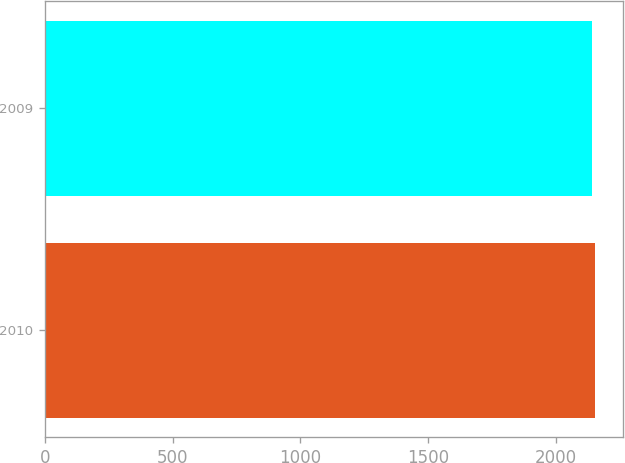Convert chart to OTSL. <chart><loc_0><loc_0><loc_500><loc_500><bar_chart><fcel>2010<fcel>2009<nl><fcel>2155.4<fcel>2142.8<nl></chart> 